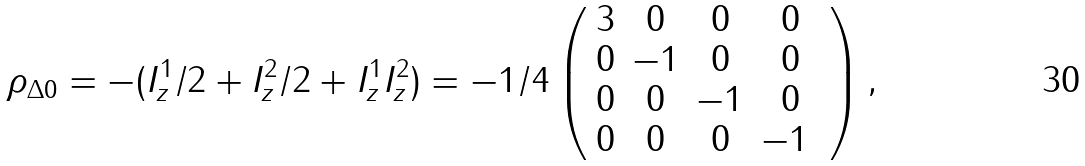Convert formula to latex. <formula><loc_0><loc_0><loc_500><loc_500>\rho _ { \Delta 0 } = - ( I _ { z } ^ { 1 } / 2 + I _ { z } ^ { 2 } / 2 + I _ { z } ^ { 1 } I _ { z } ^ { 2 } ) = - 1 / 4 \left ( \begin{array} { c c c c } 3 & 0 & 0 & 0 \\ 0 & - 1 & 0 & 0 \\ 0 & 0 & - 1 & 0 \\ 0 & 0 & 0 & - 1 \ \end{array} \right ) ,</formula> 